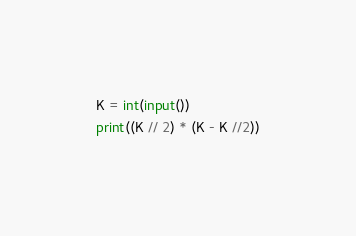<code> <loc_0><loc_0><loc_500><loc_500><_Python_>K = int(input())
print((K // 2) * (K - K //2))</code> 